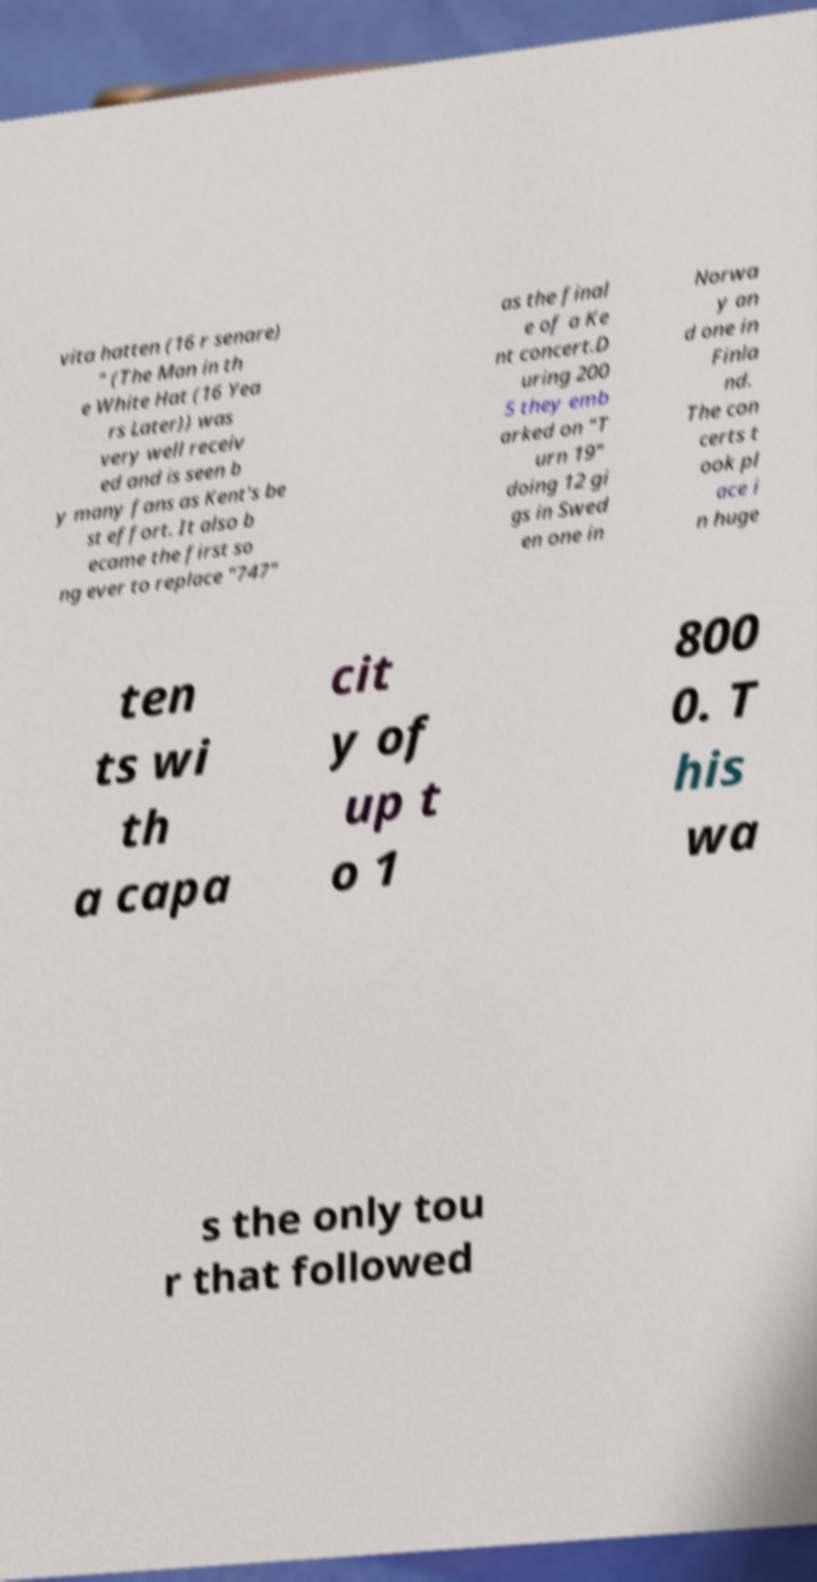For documentation purposes, I need the text within this image transcribed. Could you provide that? vita hatten (16 r senare) " (The Man in th e White Hat (16 Yea rs Later)) was very well receiv ed and is seen b y many fans as Kent's be st effort. It also b ecame the first so ng ever to replace "747" as the final e of a Ke nt concert.D uring 200 5 they emb arked on "T urn 19" doing 12 gi gs in Swed en one in Norwa y an d one in Finla nd. The con certs t ook pl ace i n huge ten ts wi th a capa cit y of up t o 1 800 0. T his wa s the only tou r that followed 